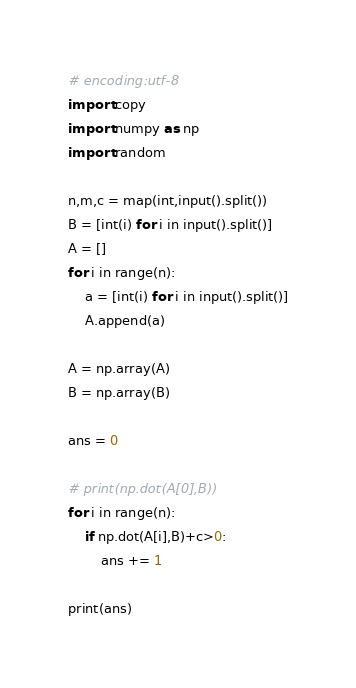<code> <loc_0><loc_0><loc_500><loc_500><_Python_># encoding:utf-8
import copy
import numpy as np
import random

n,m,c = map(int,input().split())
B = [int(i) for i in input().split()]
A = []
for i in range(n):
    a = [int(i) for i in input().split()]
    A.append(a)

A = np.array(A)
B = np.array(B)

ans = 0

# print(np.dot(A[0],B))
for i in range(n):
    if np.dot(A[i],B)+c>0:
        ans += 1

print(ans)
</code> 